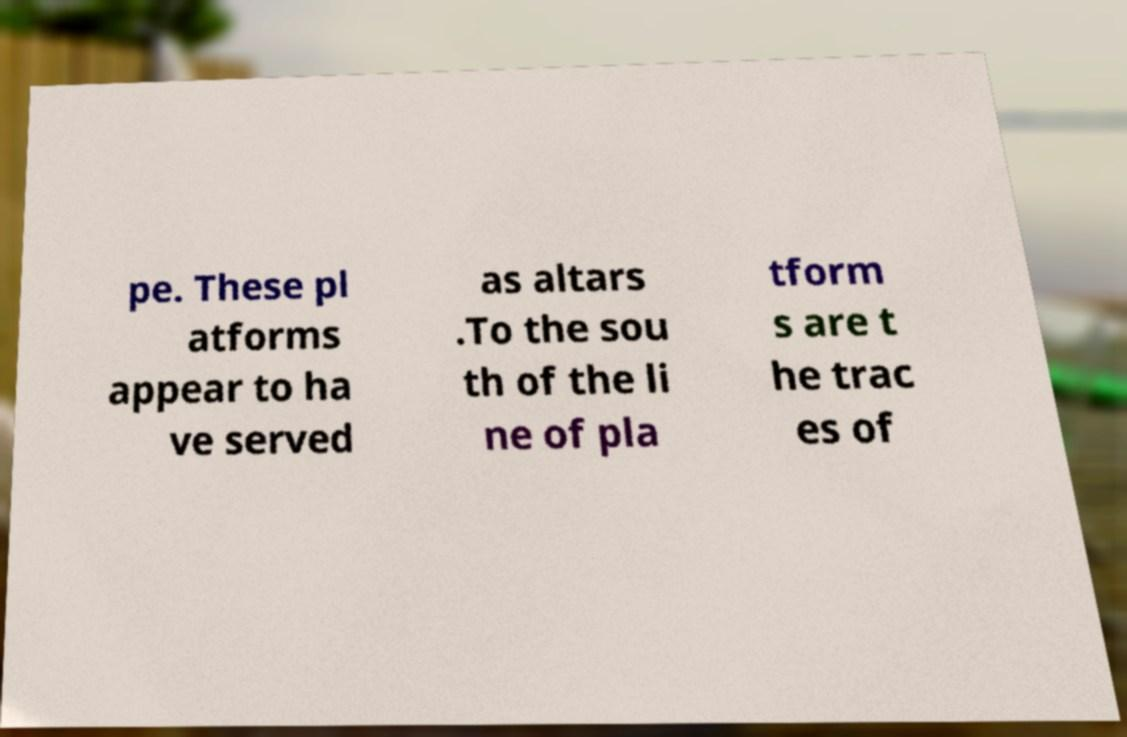There's text embedded in this image that I need extracted. Can you transcribe it verbatim? pe. These pl atforms appear to ha ve served as altars .To the sou th of the li ne of pla tform s are t he trac es of 